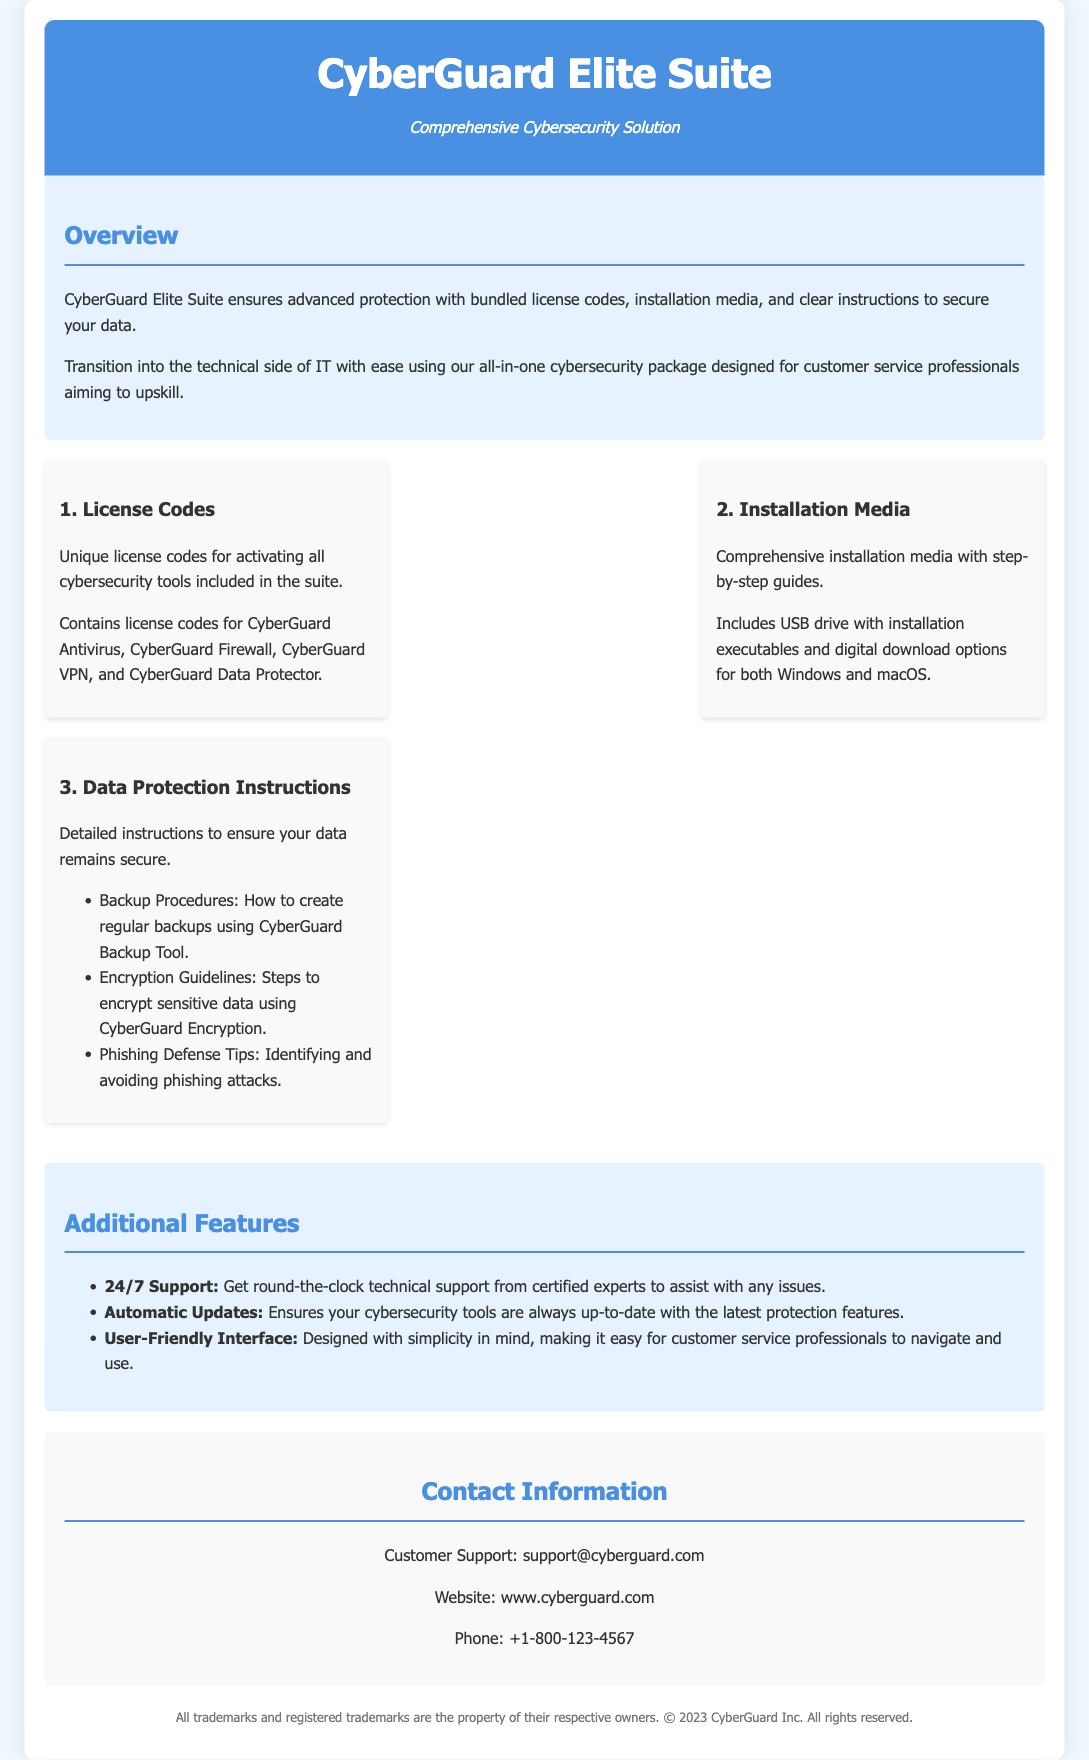What is the name of the suite? The name of the suite is provided in the header of the document.
Answer: CyberGuard Elite Suite How many cybersecurity tools are included in the license codes? The document lists the specific tools that come with license codes, which total four.
Answer: Four What types of installation media are provided? The installation media section describes what is included for installing the software and specifies the types offered.
Answer: USB drive and digital download What is a key feature of the additional features section? The document outlines several features, among which is a notable support feature mentioned.
Answer: 24/7 Support What type of instructions are included for data protection? The document explicitly lists the types of instructions that are given in the data protection section.
Answer: Detailed instructions What is an example of a phishing defense tip included? The document outlines specific data protection instructions, providing examples such as one way to avoid phishing attacks.
Answer: Identifying phishing attacks How can you contact customer support? The contact information section provides different ways to reach customer support.
Answer: support@cyberguard.com What is the website for CyberGuard? The contact information section includes the official website of the company.
Answer: www.cyberguard.com 